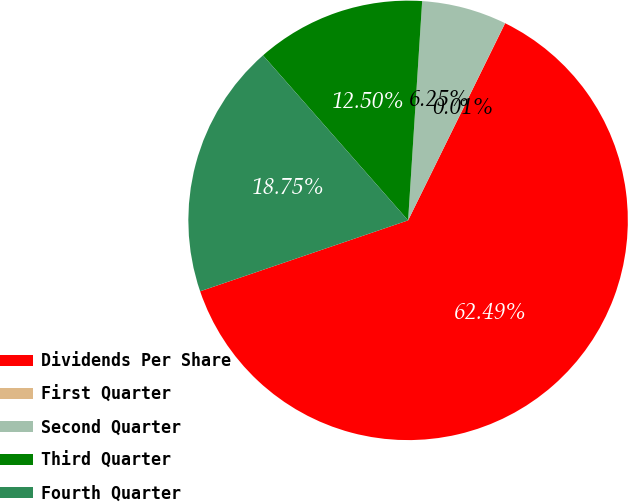Convert chart. <chart><loc_0><loc_0><loc_500><loc_500><pie_chart><fcel>Dividends Per Share<fcel>First Quarter<fcel>Second Quarter<fcel>Third Quarter<fcel>Fourth Quarter<nl><fcel>62.49%<fcel>0.01%<fcel>6.25%<fcel>12.5%<fcel>18.75%<nl></chart> 